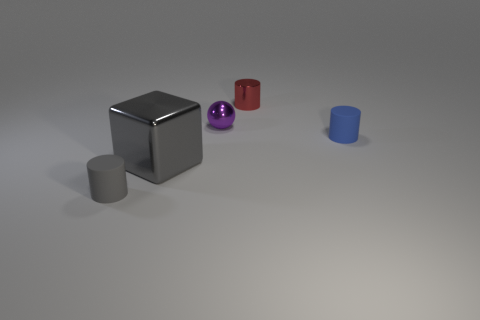Add 3 big metal blocks. How many objects exist? 8 Subtract all spheres. How many objects are left? 4 Subtract all gray matte objects. Subtract all small metallic cylinders. How many objects are left? 3 Add 2 small metal objects. How many small metal objects are left? 4 Add 5 small red metal cylinders. How many small red metal cylinders exist? 6 Subtract 0 green cubes. How many objects are left? 5 